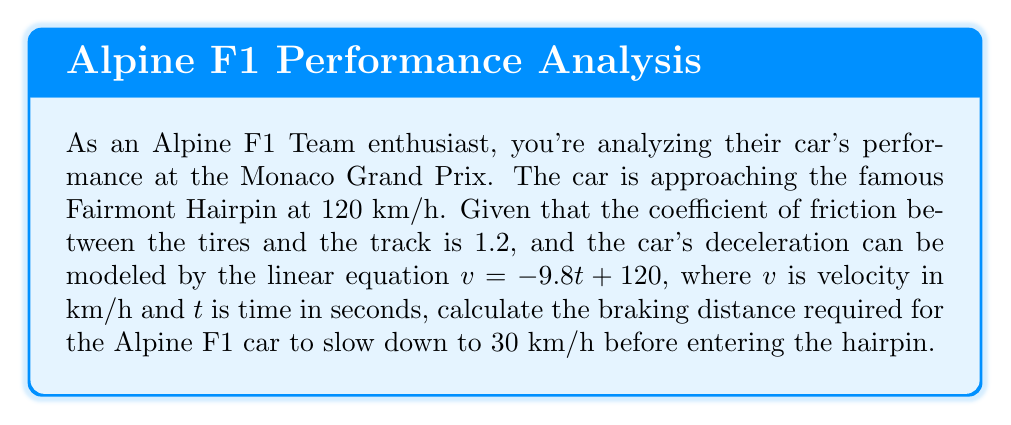Show me your answer to this math problem. Let's approach this step-by-step:

1) First, we need to find the time it takes to slow down from 120 km/h to 30 km/h using the given equation:

   $v = -9.8t + 120$
   $30 = -9.8t + 120$
   $-90 = -9.8t$
   $t = 9.18$ seconds

2) Now that we know the time, we can use the equation for distance traveled under constant deceleration:

   $d = v_0t - \frac{1}{2}at^2$

   Where:
   $d$ = distance
   $v_0$ = initial velocity
   $t$ = time
   $a$ = acceleration (deceleration in this case)

3) We need to convert the initial velocity from km/h to m/s:

   $120$ km/h = $\frac{120 * 1000}{3600}$ m/s = $33.33$ m/s

4) We can find the deceleration from the linear equation:

   $a = 9.8$ m/s² (the negative sign is already accounted for in our distance equation)

5) Now we can plug everything into our distance equation:

   $d = (33.33 * 9.18) - \frac{1}{2}(9.8)(9.18^2)$
   $d = 306.17 - 413.80$
   $d = 153.09$ meters

Therefore, the Alpine F1 car needs approximately 153.09 meters to brake from 120 km/h to 30 km/h before entering the Fairmont Hairpin.
Answer: The braking distance required for the Alpine F1 car is approximately 153.09 meters. 